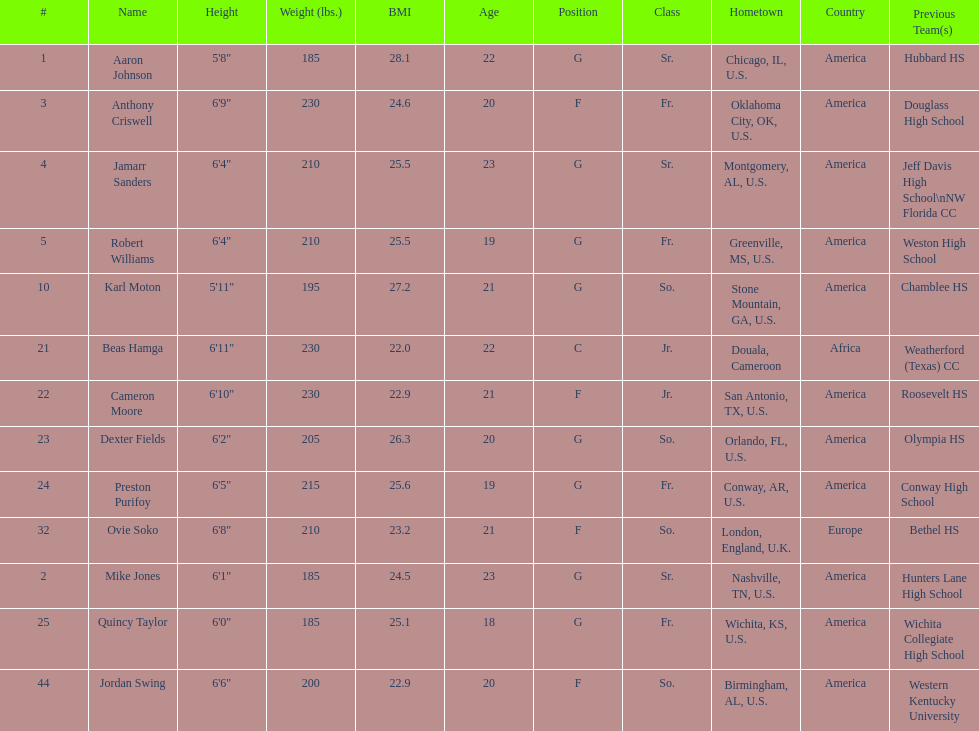Could you parse the entire table as a dict? {'header': ['#', 'Name', 'Height', 'Weight (lbs.)', 'BMI', 'Age', 'Position', 'Class', 'Hometown', 'Country', 'Previous Team(s)'], 'rows': [['1', 'Aaron Johnson', '5\'8"', '185', '28.1', '22', 'G', 'Sr.', 'Chicago, IL, U.S.', 'America', 'Hubbard HS'], ['3', 'Anthony Criswell', '6\'9"', '230', '24.6', '20', 'F', 'Fr.', 'Oklahoma City, OK, U.S.', 'America', 'Douglass High School'], ['4', 'Jamarr Sanders', '6\'4"', '210', '25.5', '23', 'G', 'Sr.', 'Montgomery, AL, U.S.', 'America', 'Jeff Davis High School\\nNW Florida CC'], ['5', 'Robert Williams', '6\'4"', '210', '25.5', '19', 'G', 'Fr.', 'Greenville, MS, U.S.', 'America', 'Weston High School'], ['10', 'Karl Moton', '5\'11"', '195', '27.2', '21', 'G', 'So.', 'Stone Mountain, GA, U.S.', 'America', 'Chamblee HS'], ['21', 'Beas Hamga', '6\'11"', '230', '22.0', '22', 'C', 'Jr.', 'Douala, Cameroon', 'Africa', 'Weatherford (Texas) CC'], ['22', 'Cameron Moore', '6\'10"', '230', '22.9', '21', 'F', 'Jr.', 'San Antonio, TX, U.S.', 'America', 'Roosevelt HS'], ['23', 'Dexter Fields', '6\'2"', '205', '26.3', '20', 'G', 'So.', 'Orlando, FL, U.S.', 'America', 'Olympia HS'], ['24', 'Preston Purifoy', '6\'5"', '215', '25.6', '19', 'G', 'Fr.', 'Conway, AR, U.S.', 'America', 'Conway High School'], ['32', 'Ovie Soko', '6\'8"', '210', '23.2', '21', 'F', 'So.', 'London, England, U.K.', 'Europe', 'Bethel HS'], ['2', 'Mike Jones', '6\'1"', '185', '24.5', '23', 'G', 'Sr.', 'Nashville, TN, U.S.', 'America', 'Hunters Lane High School'], ['25', 'Quincy Taylor', '6\'0"', '185', '25.1', '18', 'G', 'Fr.', 'Wichita, KS, U.S.', 'America', 'Wichita Collegiate High School'], ['44', 'Jordan Swing', '6\'6"', '200', '22.9', '20', 'F', 'So.', 'Birmingham, AL, U.S.', 'America', 'Western Kentucky University']]} Who is first on the roster? Aaron Johnson. 